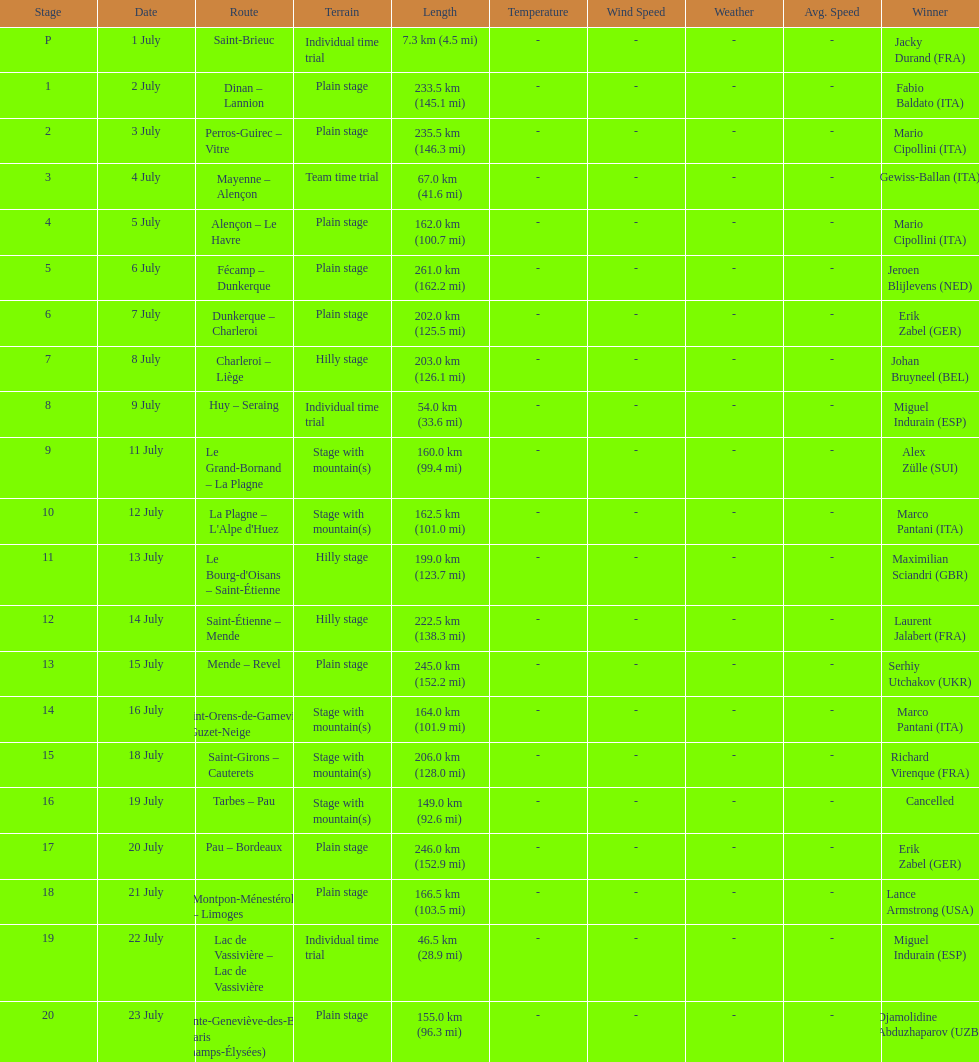Would you be able to parse every entry in this table? {'header': ['Stage', 'Date', 'Route', 'Terrain', 'Length', 'Temperature', 'Wind Speed', 'Weather', 'Avg. Speed', 'Winner'], 'rows': [['P', '1 July', 'Saint-Brieuc', 'Individual time trial', '7.3\xa0km (4.5\xa0mi)', '-', '-', '-', '-', 'Jacky Durand\xa0(FRA)'], ['1', '2 July', 'Dinan – Lannion', 'Plain stage', '233.5\xa0km (145.1\xa0mi)', '-', '-', '-', '-', 'Fabio Baldato\xa0(ITA)'], ['2', '3 July', 'Perros-Guirec – Vitre', 'Plain stage', '235.5\xa0km (146.3\xa0mi)', '-', '-', '-', '-', 'Mario Cipollini\xa0(ITA)'], ['3', '4 July', 'Mayenne – Alençon', 'Team time trial', '67.0\xa0km (41.6\xa0mi)', '-', '-', '-', '-', 'Gewiss-Ballan\xa0(ITA)'], ['4', '5 July', 'Alençon – Le Havre', 'Plain stage', '162.0\xa0km (100.7\xa0mi)', '-', '-', '-', '-', 'Mario Cipollini\xa0(ITA)'], ['5', '6 July', 'Fécamp – Dunkerque', 'Plain stage', '261.0\xa0km (162.2\xa0mi)', '-', '-', '-', '-', 'Jeroen Blijlevens\xa0(NED)'], ['6', '7 July', 'Dunkerque – Charleroi', 'Plain stage', '202.0\xa0km (125.5\xa0mi)', '-', '-', '-', '-', 'Erik Zabel\xa0(GER)'], ['7', '8 July', 'Charleroi – Liège', 'Hilly stage', '203.0\xa0km (126.1\xa0mi)', '-', '-', '-', '-', 'Johan Bruyneel\xa0(BEL)'], ['8', '9 July', 'Huy – Seraing', 'Individual time trial', '54.0\xa0km (33.6\xa0mi)', '-', '-', '-', '-', 'Miguel Indurain\xa0(ESP)'], ['9', '11 July', 'Le Grand-Bornand – La Plagne', 'Stage with mountain(s)', '160.0\xa0km (99.4\xa0mi)', '-', '-', '-', '-', 'Alex Zülle\xa0(SUI)'], ['10', '12 July', "La Plagne – L'Alpe d'Huez", 'Stage with mountain(s)', '162.5\xa0km (101.0\xa0mi)', '-', '-', '-', '-', 'Marco Pantani\xa0(ITA)'], ['11', '13 July', "Le Bourg-d'Oisans – Saint-Étienne", 'Hilly stage', '199.0\xa0km (123.7\xa0mi)', '-', '-', '-', '-', 'Maximilian Sciandri\xa0(GBR)'], ['12', '14 July', 'Saint-Étienne – Mende', 'Hilly stage', '222.5\xa0km (138.3\xa0mi)', '-', '-', '-', '-', 'Laurent Jalabert\xa0(FRA)'], ['13', '15 July', 'Mende – Revel', 'Plain stage', '245.0\xa0km (152.2\xa0mi)', '-', '-', '-', '-', 'Serhiy Utchakov\xa0(UKR)'], ['14', '16 July', 'Saint-Orens-de-Gameville – Guzet-Neige', 'Stage with mountain(s)', '164.0\xa0km (101.9\xa0mi)', '-', '-', '-', '-', 'Marco Pantani\xa0(ITA)'], ['15', '18 July', 'Saint-Girons – Cauterets', 'Stage with mountain(s)', '206.0\xa0km (128.0\xa0mi)', '-', '-', '-', '-', 'Richard Virenque\xa0(FRA)'], ['16', '19 July', 'Tarbes – Pau', 'Stage with mountain(s)', '149.0\xa0km (92.6\xa0mi)', '-', '-', '-', '-', 'Cancelled'], ['17', '20 July', 'Pau – Bordeaux', 'Plain stage', '246.0\xa0km (152.9\xa0mi)', '-', '-', '-', '-', 'Erik Zabel\xa0(GER)'], ['18', '21 July', 'Montpon-Ménestérol – Limoges', 'Plain stage', '166.5\xa0km (103.5\xa0mi)', '-', '-', '-', '-', 'Lance Armstrong\xa0(USA)'], ['19', '22 July', 'Lac de Vassivière – Lac de Vassivière', 'Individual time trial', '46.5\xa0km (28.9\xa0mi)', '-', '-', '-', '-', 'Miguel Indurain\xa0(ESP)'], ['20', '23 July', 'Sainte-Geneviève-des-Bois – Paris (Champs-Élysées)', 'Plain stage', '155.0\xa0km (96.3\xa0mi)', '-', '-', '-', '-', 'Djamolidine Abduzhaparov\xa0(UZB)']]} How much longer is the 20th tour de france stage than the 19th? 108.5 km. 